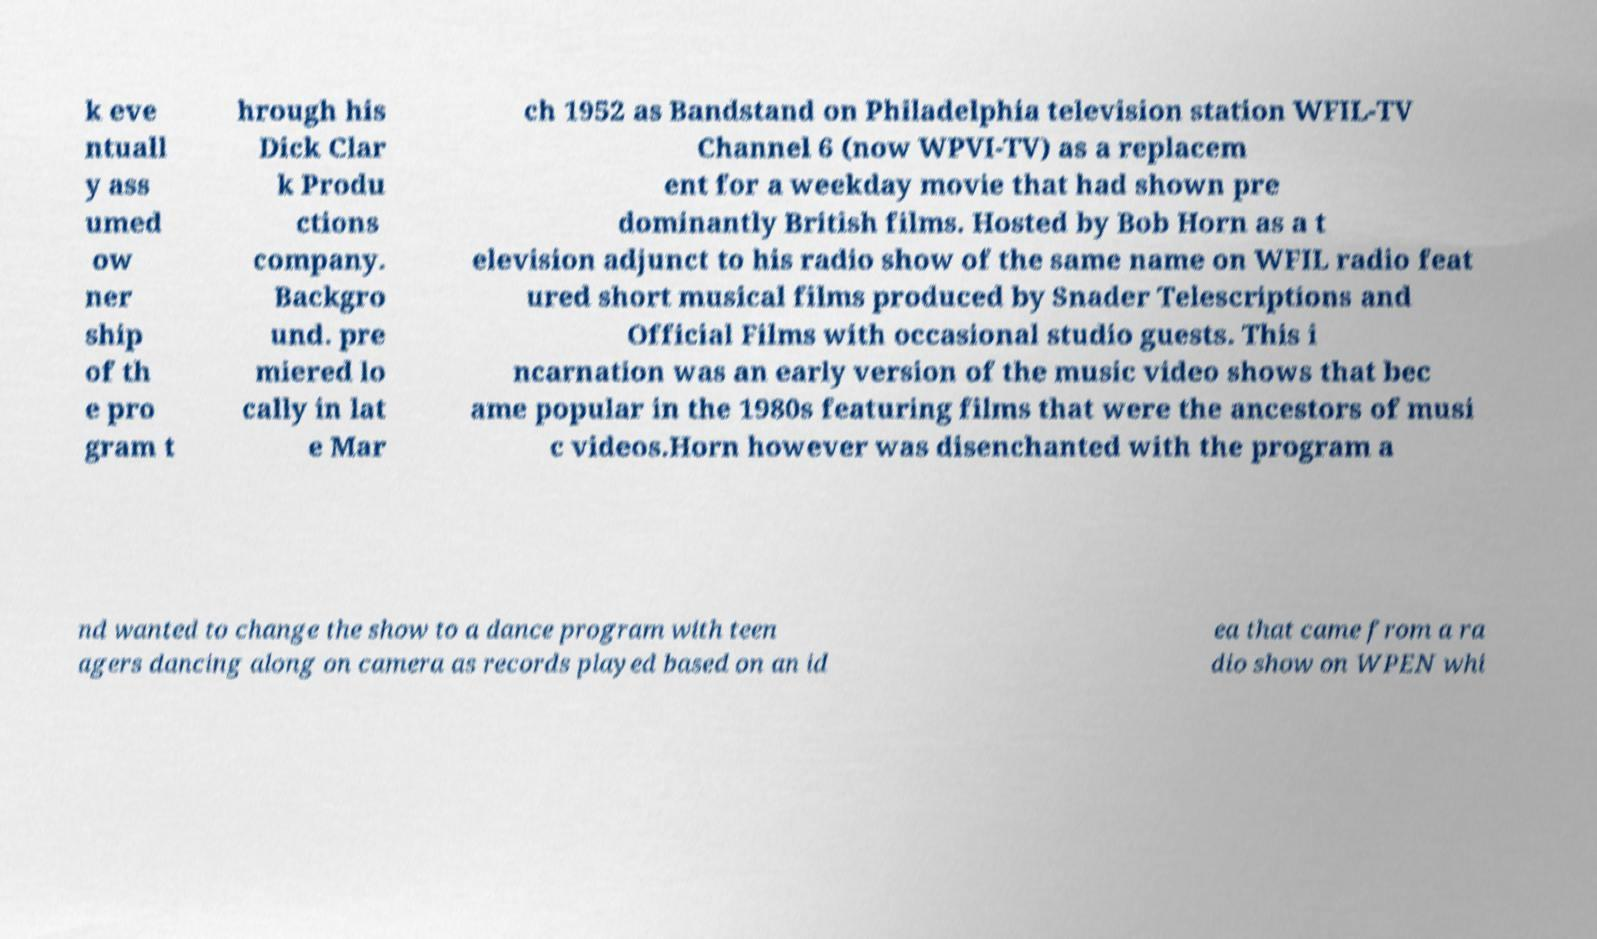Can you accurately transcribe the text from the provided image for me? k eve ntuall y ass umed ow ner ship of th e pro gram t hrough his Dick Clar k Produ ctions company. Backgro und. pre miered lo cally in lat e Mar ch 1952 as Bandstand on Philadelphia television station WFIL-TV Channel 6 (now WPVI-TV) as a replacem ent for a weekday movie that had shown pre dominantly British films. Hosted by Bob Horn as a t elevision adjunct to his radio show of the same name on WFIL radio feat ured short musical films produced by Snader Telescriptions and Official Films with occasional studio guests. This i ncarnation was an early version of the music video shows that bec ame popular in the 1980s featuring films that were the ancestors of musi c videos.Horn however was disenchanted with the program a nd wanted to change the show to a dance program with teen agers dancing along on camera as records played based on an id ea that came from a ra dio show on WPEN whi 